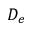<formula> <loc_0><loc_0><loc_500><loc_500>D _ { e }</formula> 